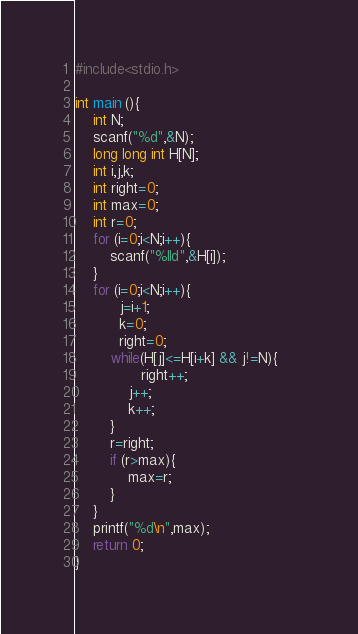Convert code to text. <code><loc_0><loc_0><loc_500><loc_500><_C_>#include<stdio.h>

int main (){
	int N;
	scanf("%d",&N);
	long long int H[N];
	int i,j,k;
	int right=0;
	int max=0;
	int r=0;
	for (i=0;i<N;i++){
		scanf("%lld",&H[i]);
	}
	for (i=0;i<N;i++){
          j=i+1;
          k=0;
          right=0;
		while(H[j]<=H[i+k] && j!=N){    
               right++;
          	j++;
          	k++;
		}
		r=right;
		if (r>max){
			max=r;
		}	
	}
	printf("%d\n",max);
	return 0;
}
</code> 